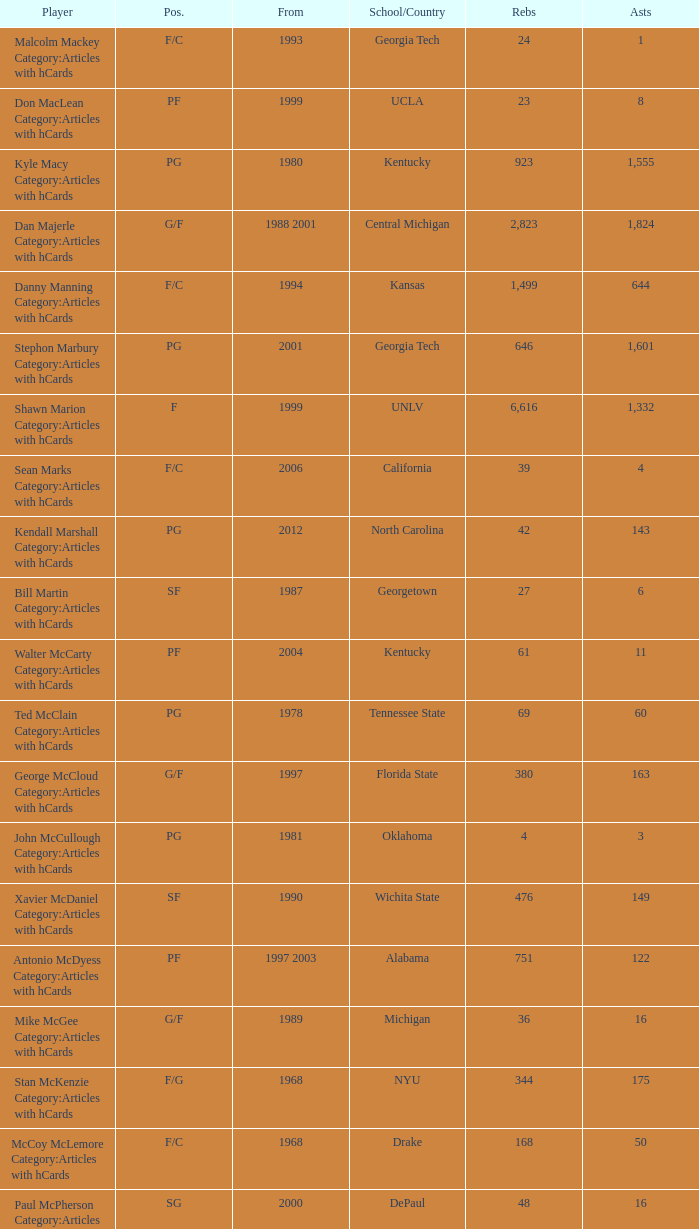Who has the high assists in 2000? 16.0. 